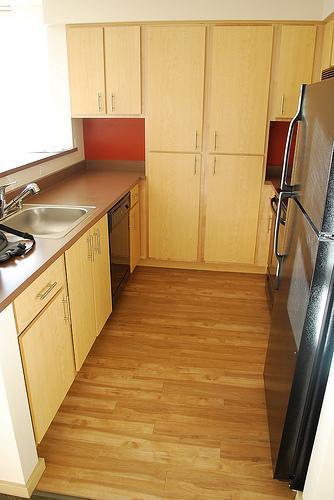How many cabinet doors are in the photo?
Give a very brief answer. 10. 